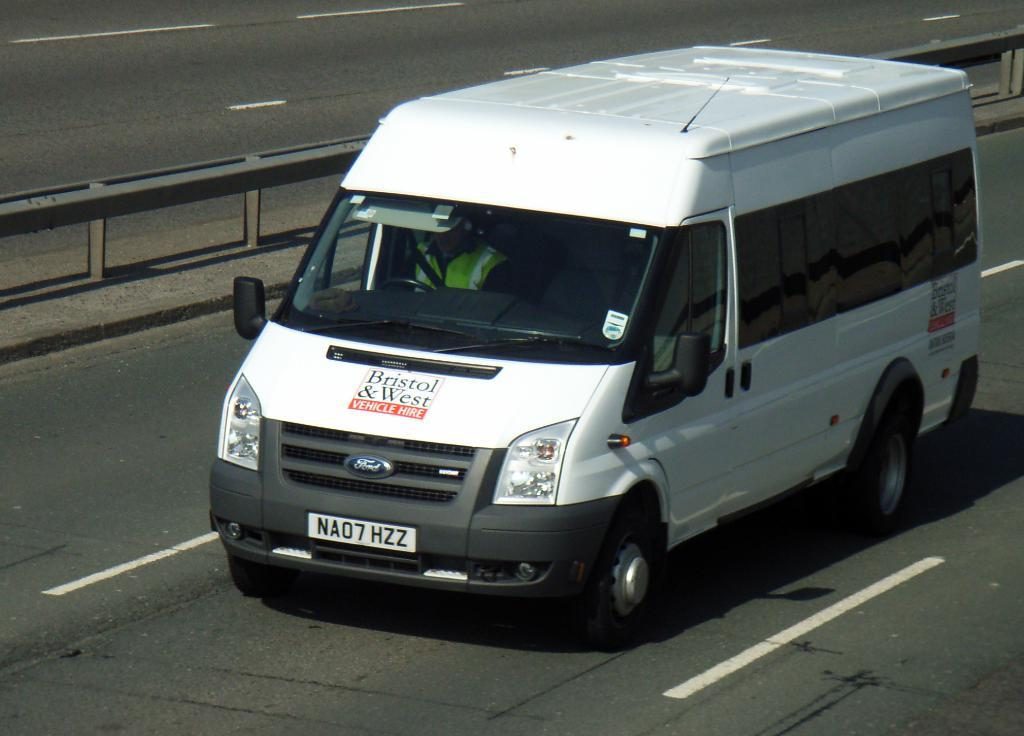Provide a one-sentence caption for the provided image. A Bristol & West van was built by the Ford Motor Company. 